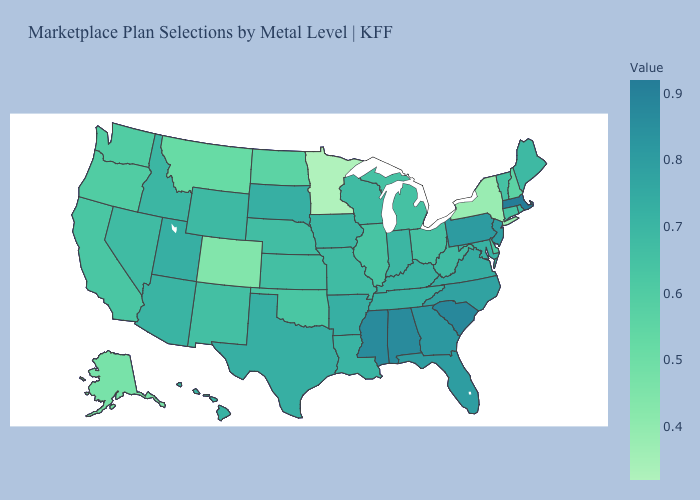Does Maryland have the lowest value in the South?
Write a very short answer. No. Which states have the lowest value in the USA?
Keep it brief. Minnesota. Among the states that border Connecticut , which have the lowest value?
Answer briefly. New York. Does West Virginia have a lower value than New Jersey?
Be succinct. Yes. 